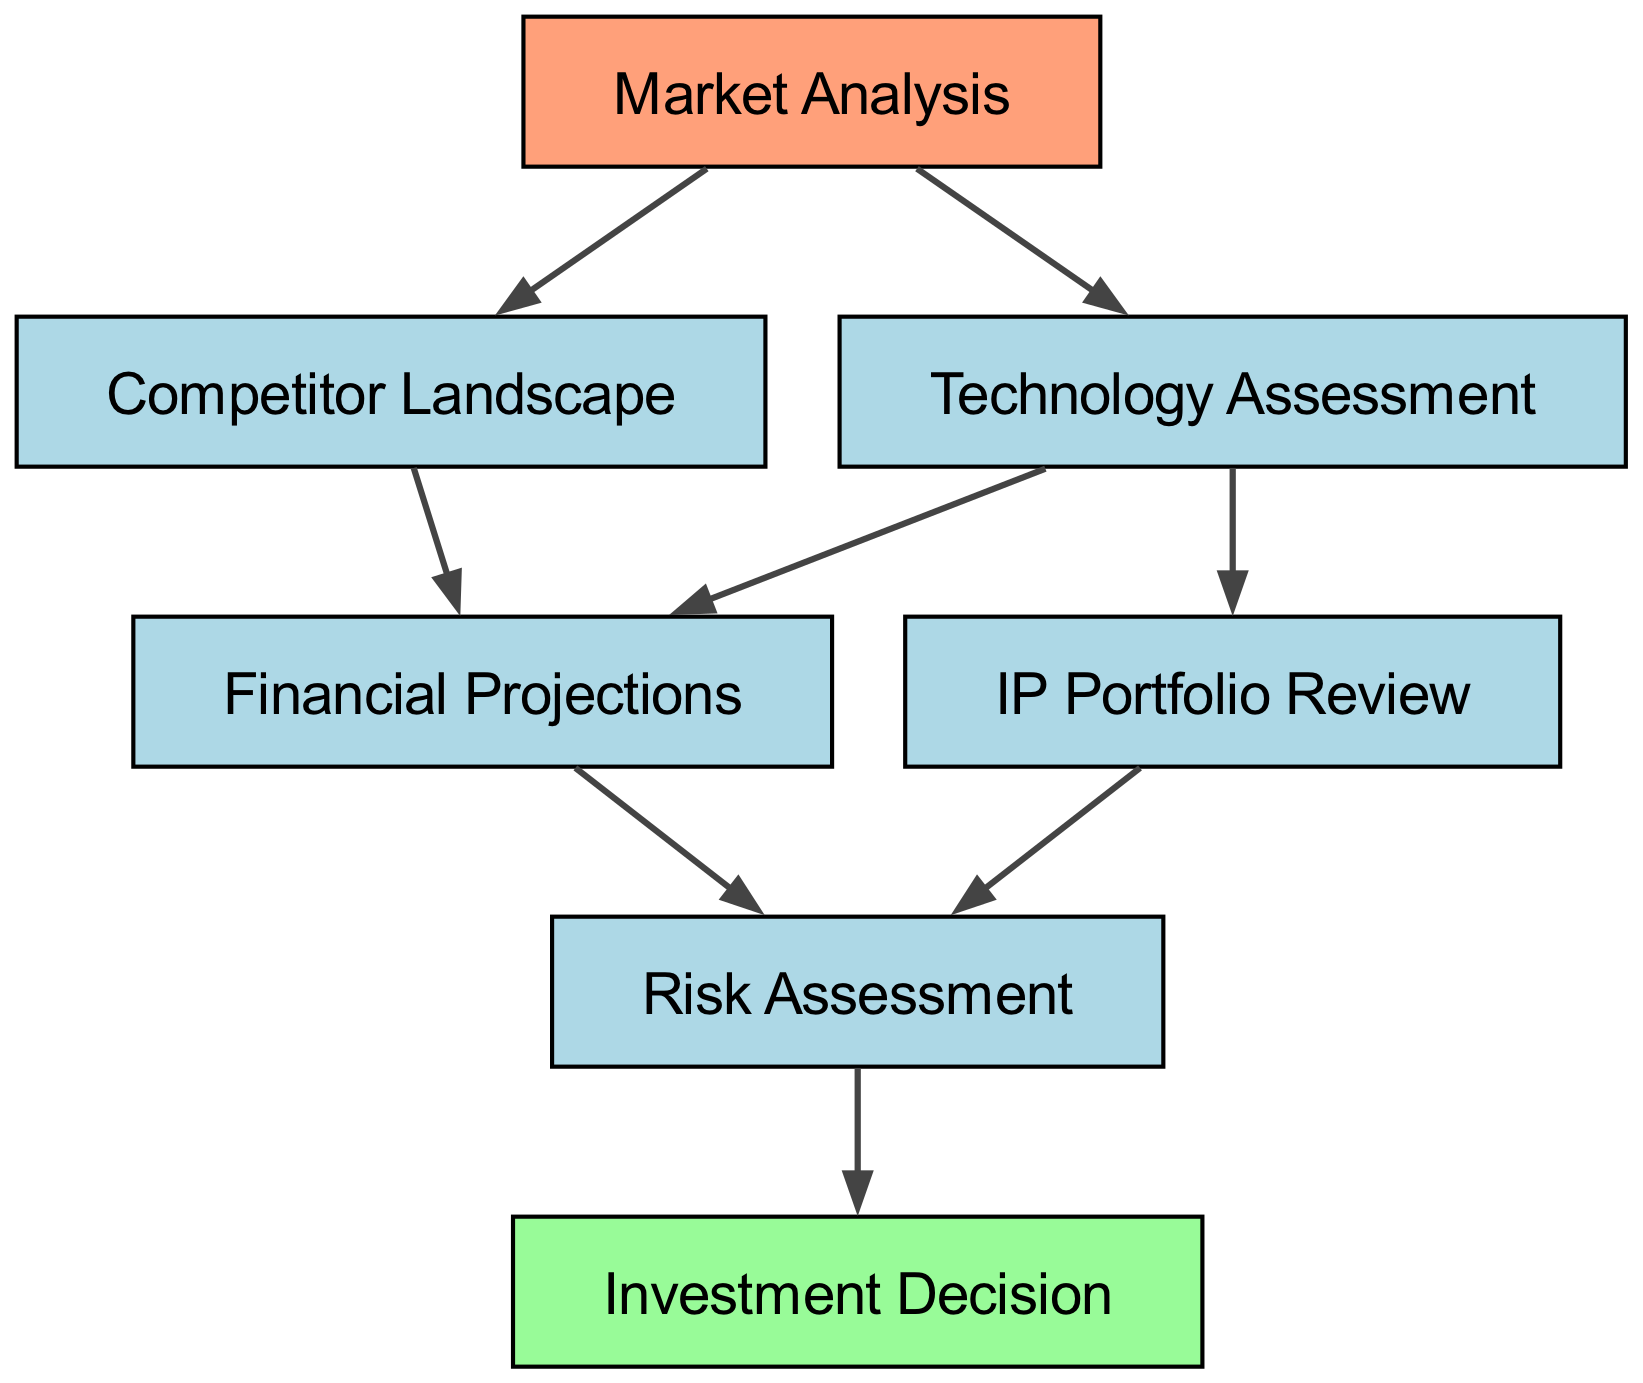What's the first step in the due diligence process? The first node in the diagram is "Market Analysis," which indicates it's the initial step taken in the due diligence process for evaluating investments.
Answer: Market Analysis How many total nodes are in the diagram? By counting each element listed, there are seven distinct nodes in the diagram, representing various stages in the due diligence process.
Answer: Seven What are the final steps after "Risk Assessment"? The final step that follows "Risk Assessment" is "Investment Decision," indicating the outcome of the evaluation process.
Answer: Investment Decision Which nodes connect to "Technology Assessment"? The nodes that connect to "Technology Assessment" are "Financial Projections" and "IP Portfolio Review," illustrating the further assessments stemming from this evaluation.
Answer: Financial Projections, IP Portfolio Review What is the relationship between "Competitor Landscape" and "Financial Projections"? "Competitor Landscape" feeds into "Financial Projections," showing that the analysis of competitors plays a role in projecting financial outcomes.
Answer: Competitor Landscape → Financial Projections If the assessment of the IP portfolio is positive, which node is next? After "IP Portfolio Review," both "Risk Assessment" and "Financial Projections" are the next steps, indicating that a positive IP assessment will lead to further evaluations in both areas.
Answer: Risk Assessment, Financial Projections Which single node is not a connection origin? The final node, "Investment Decision," does not have any outgoing connections, indicating it is an endpoint in the evaluation process.
Answer: Investment Decision How many connections are from "Market Analysis"? "Market Analysis" connects to two other nodes, namely "Technology Assessment" and "Competitor Landscape," showing that it branches into two different areas of assessment.
Answer: Two 